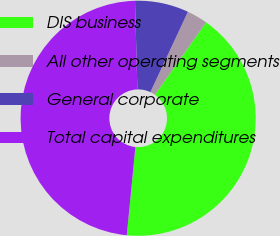<chart> <loc_0><loc_0><loc_500><loc_500><pie_chart><fcel>DIS business<fcel>All other operating segments<fcel>General corporate<fcel>Total capital expenditures<nl><fcel>41.74%<fcel>2.86%<fcel>7.38%<fcel>48.03%<nl></chart> 